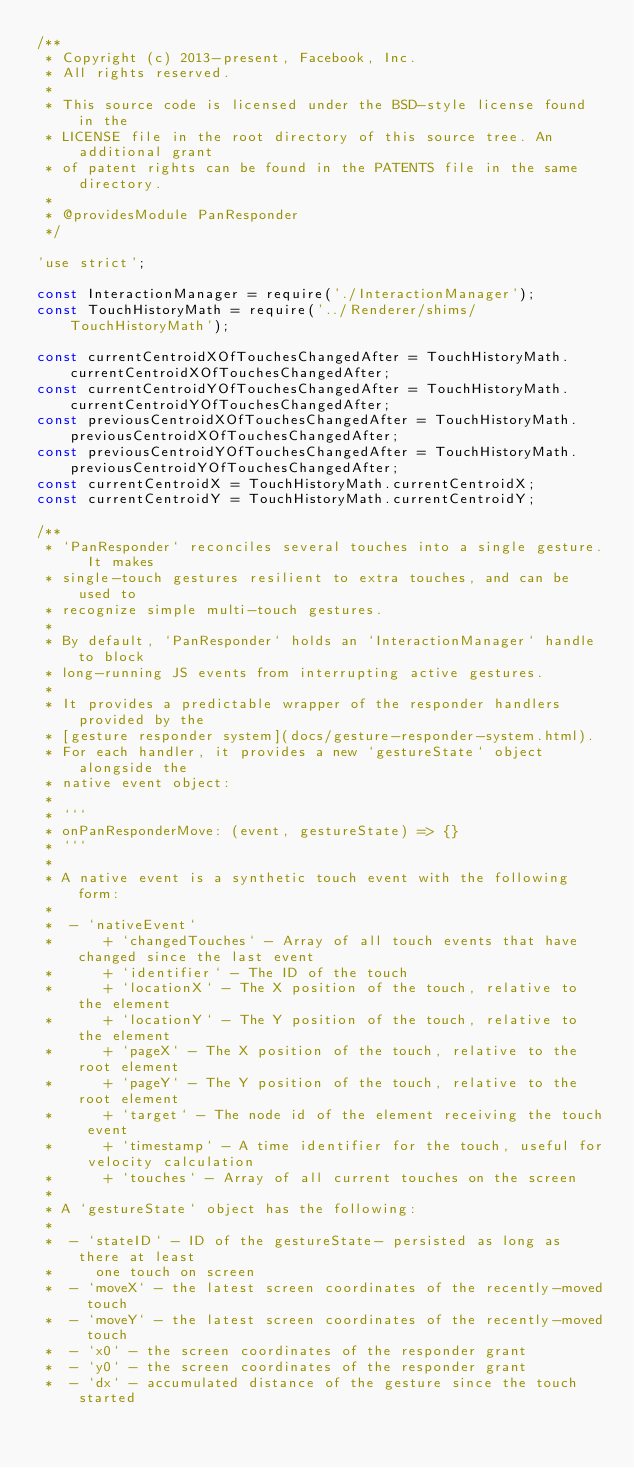Convert code to text. <code><loc_0><loc_0><loc_500><loc_500><_JavaScript_>/**
 * Copyright (c) 2013-present, Facebook, Inc.
 * All rights reserved.
 *
 * This source code is licensed under the BSD-style license found in the
 * LICENSE file in the root directory of this source tree. An additional grant
 * of patent rights can be found in the PATENTS file in the same directory.
 *
 * @providesModule PanResponder
 */

'use strict';

const InteractionManager = require('./InteractionManager');
const TouchHistoryMath = require('../Renderer/shims/TouchHistoryMath');

const currentCentroidXOfTouchesChangedAfter = TouchHistoryMath.currentCentroidXOfTouchesChangedAfter;
const currentCentroidYOfTouchesChangedAfter = TouchHistoryMath.currentCentroidYOfTouchesChangedAfter;
const previousCentroidXOfTouchesChangedAfter = TouchHistoryMath.previousCentroidXOfTouchesChangedAfter;
const previousCentroidYOfTouchesChangedAfter = TouchHistoryMath.previousCentroidYOfTouchesChangedAfter;
const currentCentroidX = TouchHistoryMath.currentCentroidX;
const currentCentroidY = TouchHistoryMath.currentCentroidY;

/**
 * `PanResponder` reconciles several touches into a single gesture. It makes
 * single-touch gestures resilient to extra touches, and can be used to
 * recognize simple multi-touch gestures.
 *
 * By default, `PanResponder` holds an `InteractionManager` handle to block
 * long-running JS events from interrupting active gestures.
 *
 * It provides a predictable wrapper of the responder handlers provided by the
 * [gesture responder system](docs/gesture-responder-system.html).
 * For each handler, it provides a new `gestureState` object alongside the
 * native event object:
 *
 * ```
 * onPanResponderMove: (event, gestureState) => {}
 * ```
 *
 * A native event is a synthetic touch event with the following form:
 *
 *  - `nativeEvent`
 *      + `changedTouches` - Array of all touch events that have changed since the last event
 *      + `identifier` - The ID of the touch
 *      + `locationX` - The X position of the touch, relative to the element
 *      + `locationY` - The Y position of the touch, relative to the element
 *      + `pageX` - The X position of the touch, relative to the root element
 *      + `pageY` - The Y position of the touch, relative to the root element
 *      + `target` - The node id of the element receiving the touch event
 *      + `timestamp` - A time identifier for the touch, useful for velocity calculation
 *      + `touches` - Array of all current touches on the screen
 *
 * A `gestureState` object has the following:
 *
 *  - `stateID` - ID of the gestureState- persisted as long as there at least
 *     one touch on screen
 *  - `moveX` - the latest screen coordinates of the recently-moved touch
 *  - `moveY` - the latest screen coordinates of the recently-moved touch
 *  - `x0` - the screen coordinates of the responder grant
 *  - `y0` - the screen coordinates of the responder grant
 *  - `dx` - accumulated distance of the gesture since the touch started</code> 